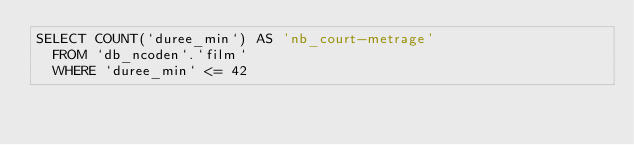<code> <loc_0><loc_0><loc_500><loc_500><_SQL_>SELECT COUNT(`duree_min`) AS 'nb_court-metrage'
	FROM `db_ncoden`.`film`
	WHERE `duree_min` <= 42</code> 